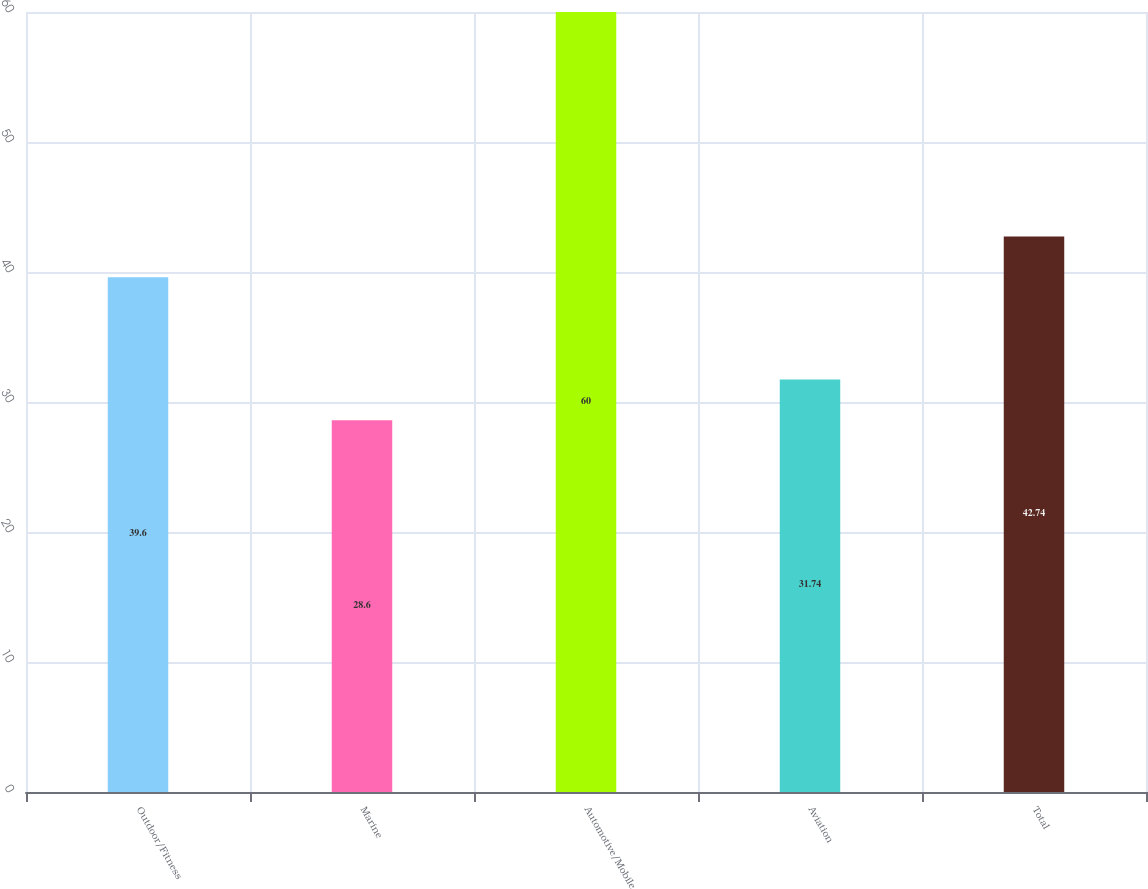Convert chart to OTSL. <chart><loc_0><loc_0><loc_500><loc_500><bar_chart><fcel>Outdoor/Fitness<fcel>Marine<fcel>Automotive/Mobile<fcel>Aviation<fcel>Total<nl><fcel>39.6<fcel>28.6<fcel>60<fcel>31.74<fcel>42.74<nl></chart> 